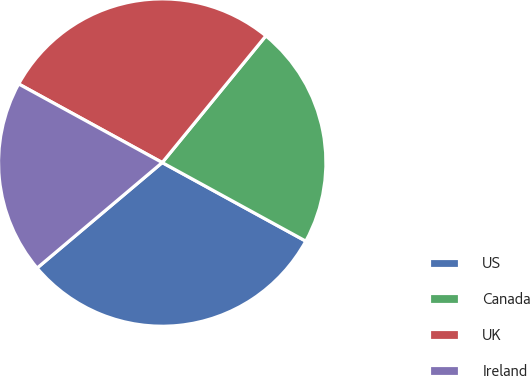Convert chart to OTSL. <chart><loc_0><loc_0><loc_500><loc_500><pie_chart><fcel>US<fcel>Canada<fcel>UK<fcel>Ireland<nl><fcel>30.88%<fcel>22.06%<fcel>27.94%<fcel>19.12%<nl></chart> 